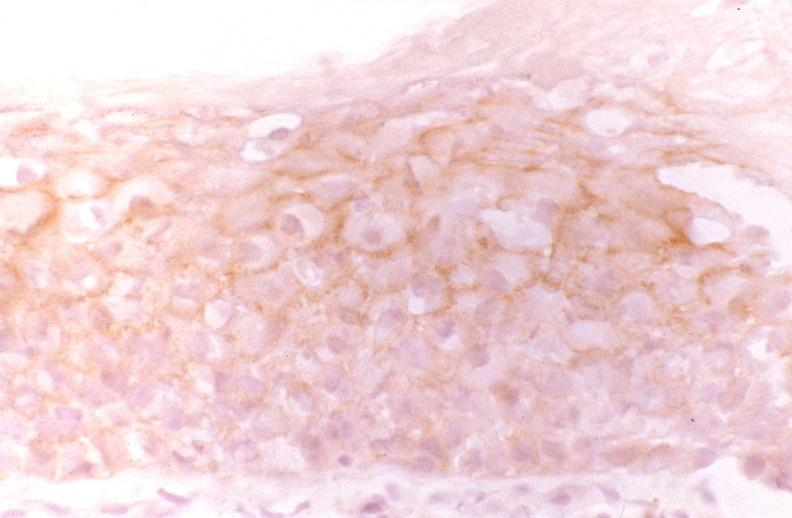does this image show oral dysplasia, neu?
Answer the question using a single word or phrase. Yes 